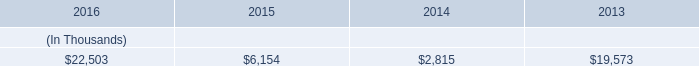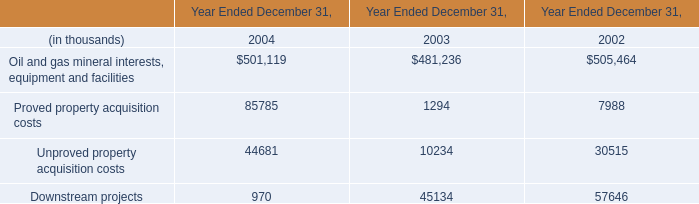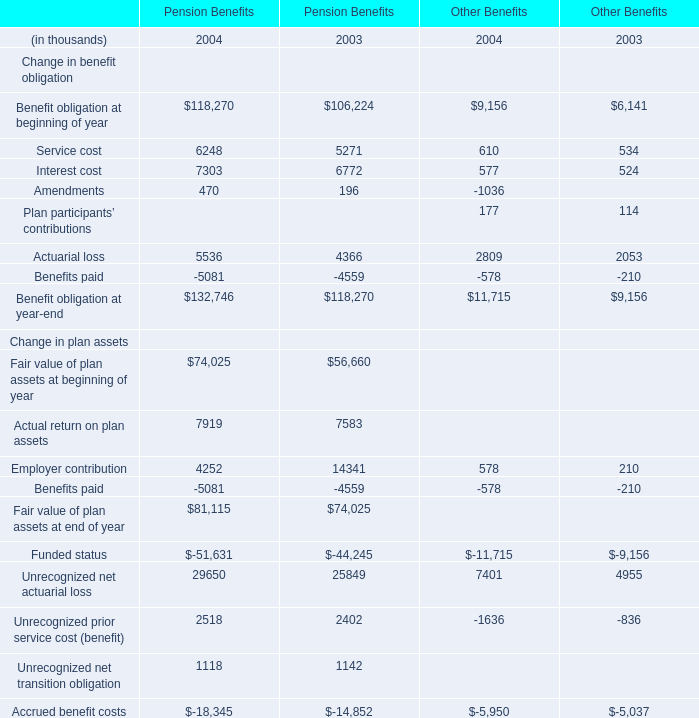What's the growth rate of Fair value of plan assets at beginning of year for Pension Benefits in 2004? 
Computations: ((74025 - 56660) / 56660)
Answer: 0.30648. 